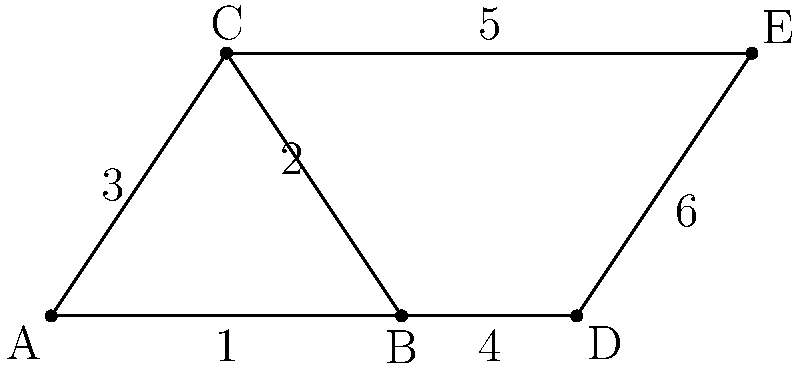In the truss structure shown above, triangles ABC and CDE are congruent. If the length of side 1 is 4 units and the length of side 3 is 3.6 units, what is the length of side 6? To solve this problem, we'll use the properties of congruent triangles and the given information. Let's proceed step by step:

1) First, recall that congruent triangles have all corresponding sides and angles equal.

2) Given: 
   - Triangles ABC and CDE are congruent
   - Length of side 1 (AB) = 4 units
   - Length of side 3 (AC) = 3.6 units

3) Since the triangles are congruent:
   - Side 1 (AB) corresponds to side 4 (BD)
   - Side 2 (BC) corresponds to side 5 (CE)
   - Side 3 (AC) corresponds to side 6 (DE)

4) Therefore:
   - Length of side 4 (BD) = Length of side 1 (AB) = 4 units
   - Length of side 6 (DE) = Length of side 3 (AC) = 3.6 units

5) The question asks for the length of side 6, which we've determined to be 3.6 units.
Answer: 3.6 units 